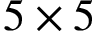Convert formula to latex. <formula><loc_0><loc_0><loc_500><loc_500>5 \times 5</formula> 